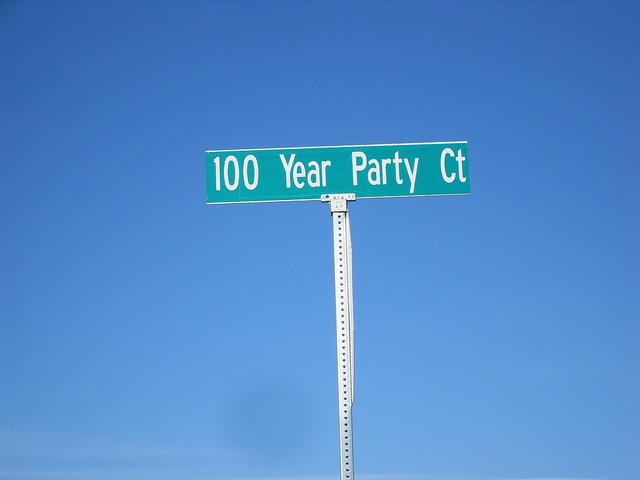Describe the objects in this image and their specific colors. I can see various objects in this image with different colors. 